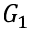<formula> <loc_0><loc_0><loc_500><loc_500>G _ { 1 }</formula> 